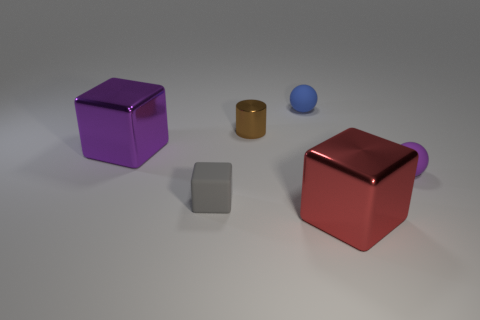Can you describe the shapes and colors of the objects? Certainly! There are four objects in the image: a purple cube, a metallic cylinder that has a reflective surface, a small blue sphere, and a red cube with a protruding handle which suggests it might be a container of some sort. 